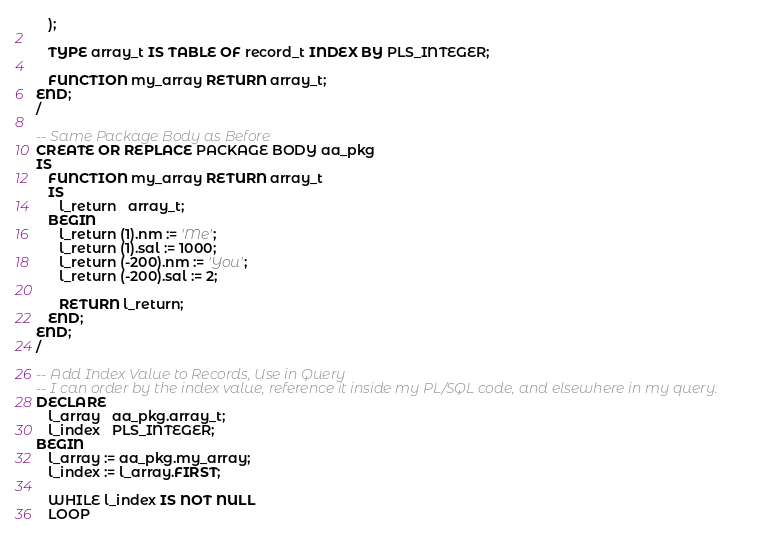<code> <loc_0><loc_0><loc_500><loc_500><_SQL_>   );  
  
   TYPE array_t IS TABLE OF record_t INDEX BY PLS_INTEGER;  
  
   FUNCTION my_array RETURN array_t;  
END; 
/

-- Same Package Body as Before
CREATE OR REPLACE PACKAGE BODY aa_pkg  
IS  
   FUNCTION my_array RETURN array_t  
   IS  
      l_return   array_t;  
   BEGIN  
      l_return (1).nm := 'Me';  
      l_return (1).sal := 1000;  
      l_return (-200).nm := 'You';  
      l_return (-200).sal := 2;  
  
      RETURN l_return;  
   END;  
END; 
/

-- Add Index Value to Records, Use in Query
-- I can order by the index value, reference it inside my PL/SQL code, and elsewhere in my query. 
DECLARE  
   l_array   aa_pkg.array_t;  
   l_index   PLS_INTEGER;  
BEGIN  
   l_array := aa_pkg.my_array;  
   l_index := l_array.FIRST;  
  
   WHILE l_index IS NOT NULL  
   LOOP  </code> 